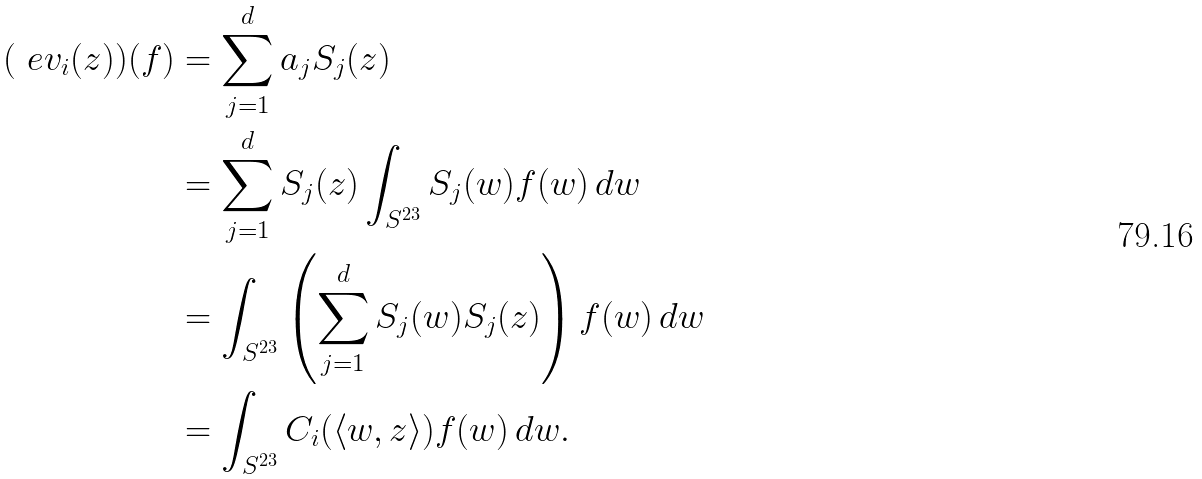Convert formula to latex. <formula><loc_0><loc_0><loc_500><loc_500>( \ e v _ { i } ( z ) ) ( f ) & = \sum _ { j = 1 } ^ { d } a _ { j } S _ { j } ( z ) \\ & = \sum _ { j = 1 } ^ { d } S _ { j } ( z ) \int _ { S ^ { 2 3 } } S _ { j } ( w ) f ( w ) \, d w \\ & = \int _ { S ^ { 2 3 } } \left ( \sum _ { j = 1 } ^ { d } S _ { j } ( w ) S _ { j } ( z ) \right ) f ( w ) \, d w \\ & = \int _ { S ^ { 2 3 } } C _ { i } ( \langle w , z \rangle ) f ( w ) \, d w .</formula> 